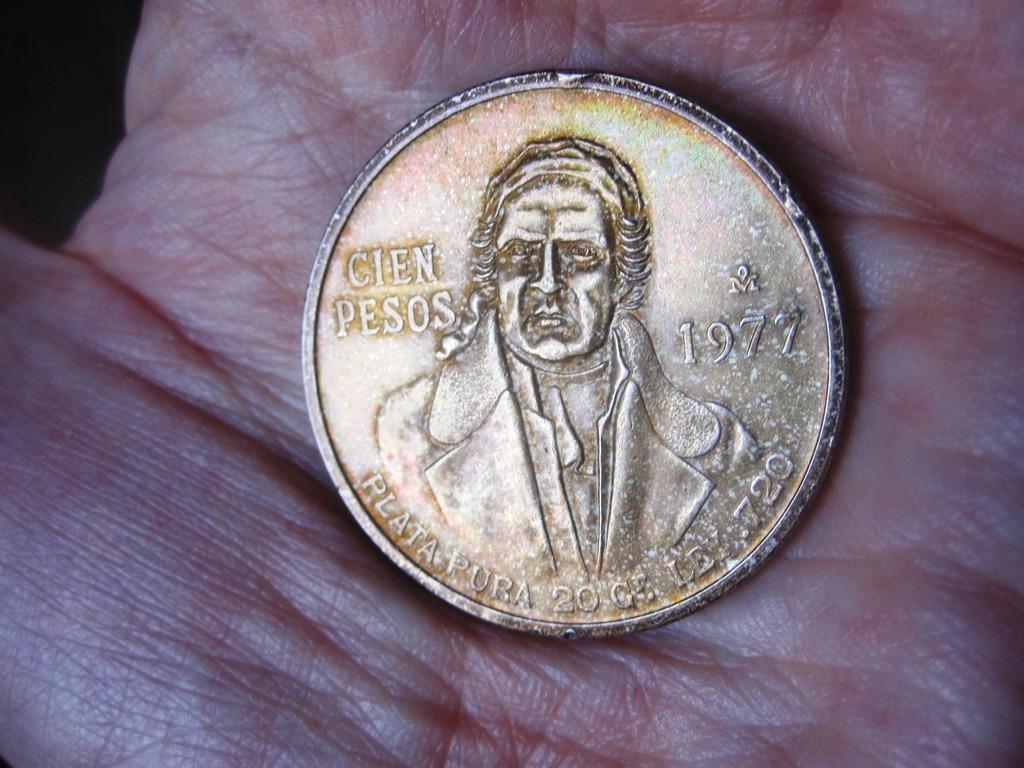<image>
Provide a brief description of the given image. Coin dated back to 1977 of Cien Pesos. 